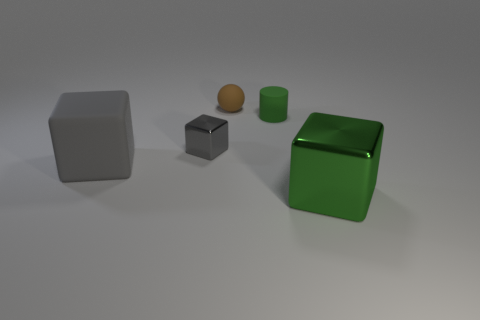What might be the purpose of creating this image? This image could serve multiple purposes: it might be used as a visual aid for discussing concepts such as geometry, shading in art classes, or demonstrating rendering techniques in computer graphics. It could also function as a placeholder or a test render in a 3D modeling software. 